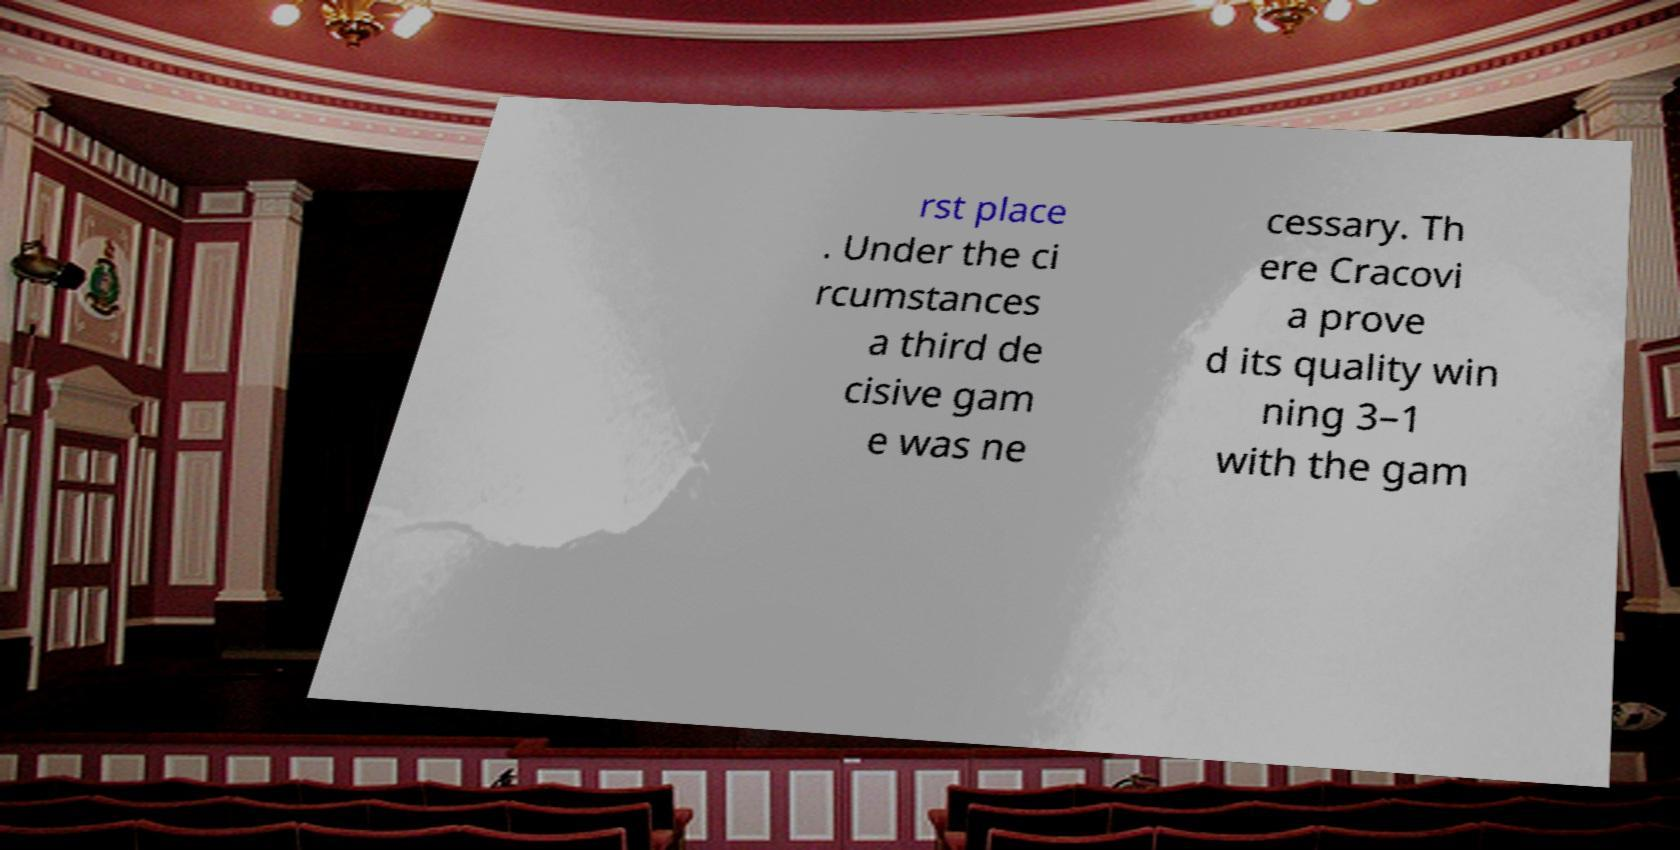I need the written content from this picture converted into text. Can you do that? rst place . Under the ci rcumstances a third de cisive gam e was ne cessary. Th ere Cracovi a prove d its quality win ning 3–1 with the gam 